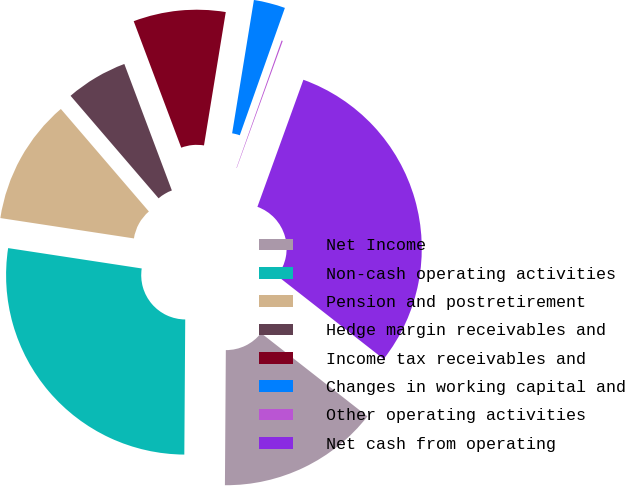Convert chart. <chart><loc_0><loc_0><loc_500><loc_500><pie_chart><fcel>Net Income<fcel>Non-cash operating activities<fcel>Pension and postretirement<fcel>Hedge margin receivables and<fcel>Income tax receivables and<fcel>Changes in working capital and<fcel>Other operating activities<fcel>Net cash from operating<nl><fcel>14.54%<fcel>27.3%<fcel>11.3%<fcel>5.57%<fcel>8.3%<fcel>2.84%<fcel>0.11%<fcel>30.04%<nl></chart> 